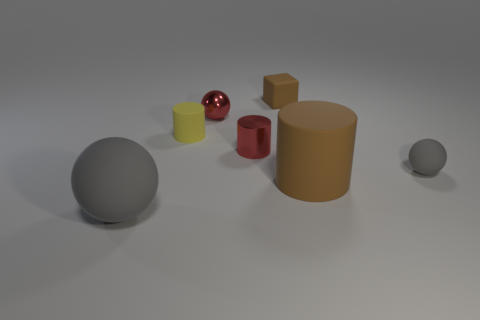How many other objects are the same color as the large rubber cylinder? There is one other object that shares the same color as the large rubber cylinder: a small rubber cube. The colors appear identical, providing a pleasant symmetry in hues among the varied shapes. 